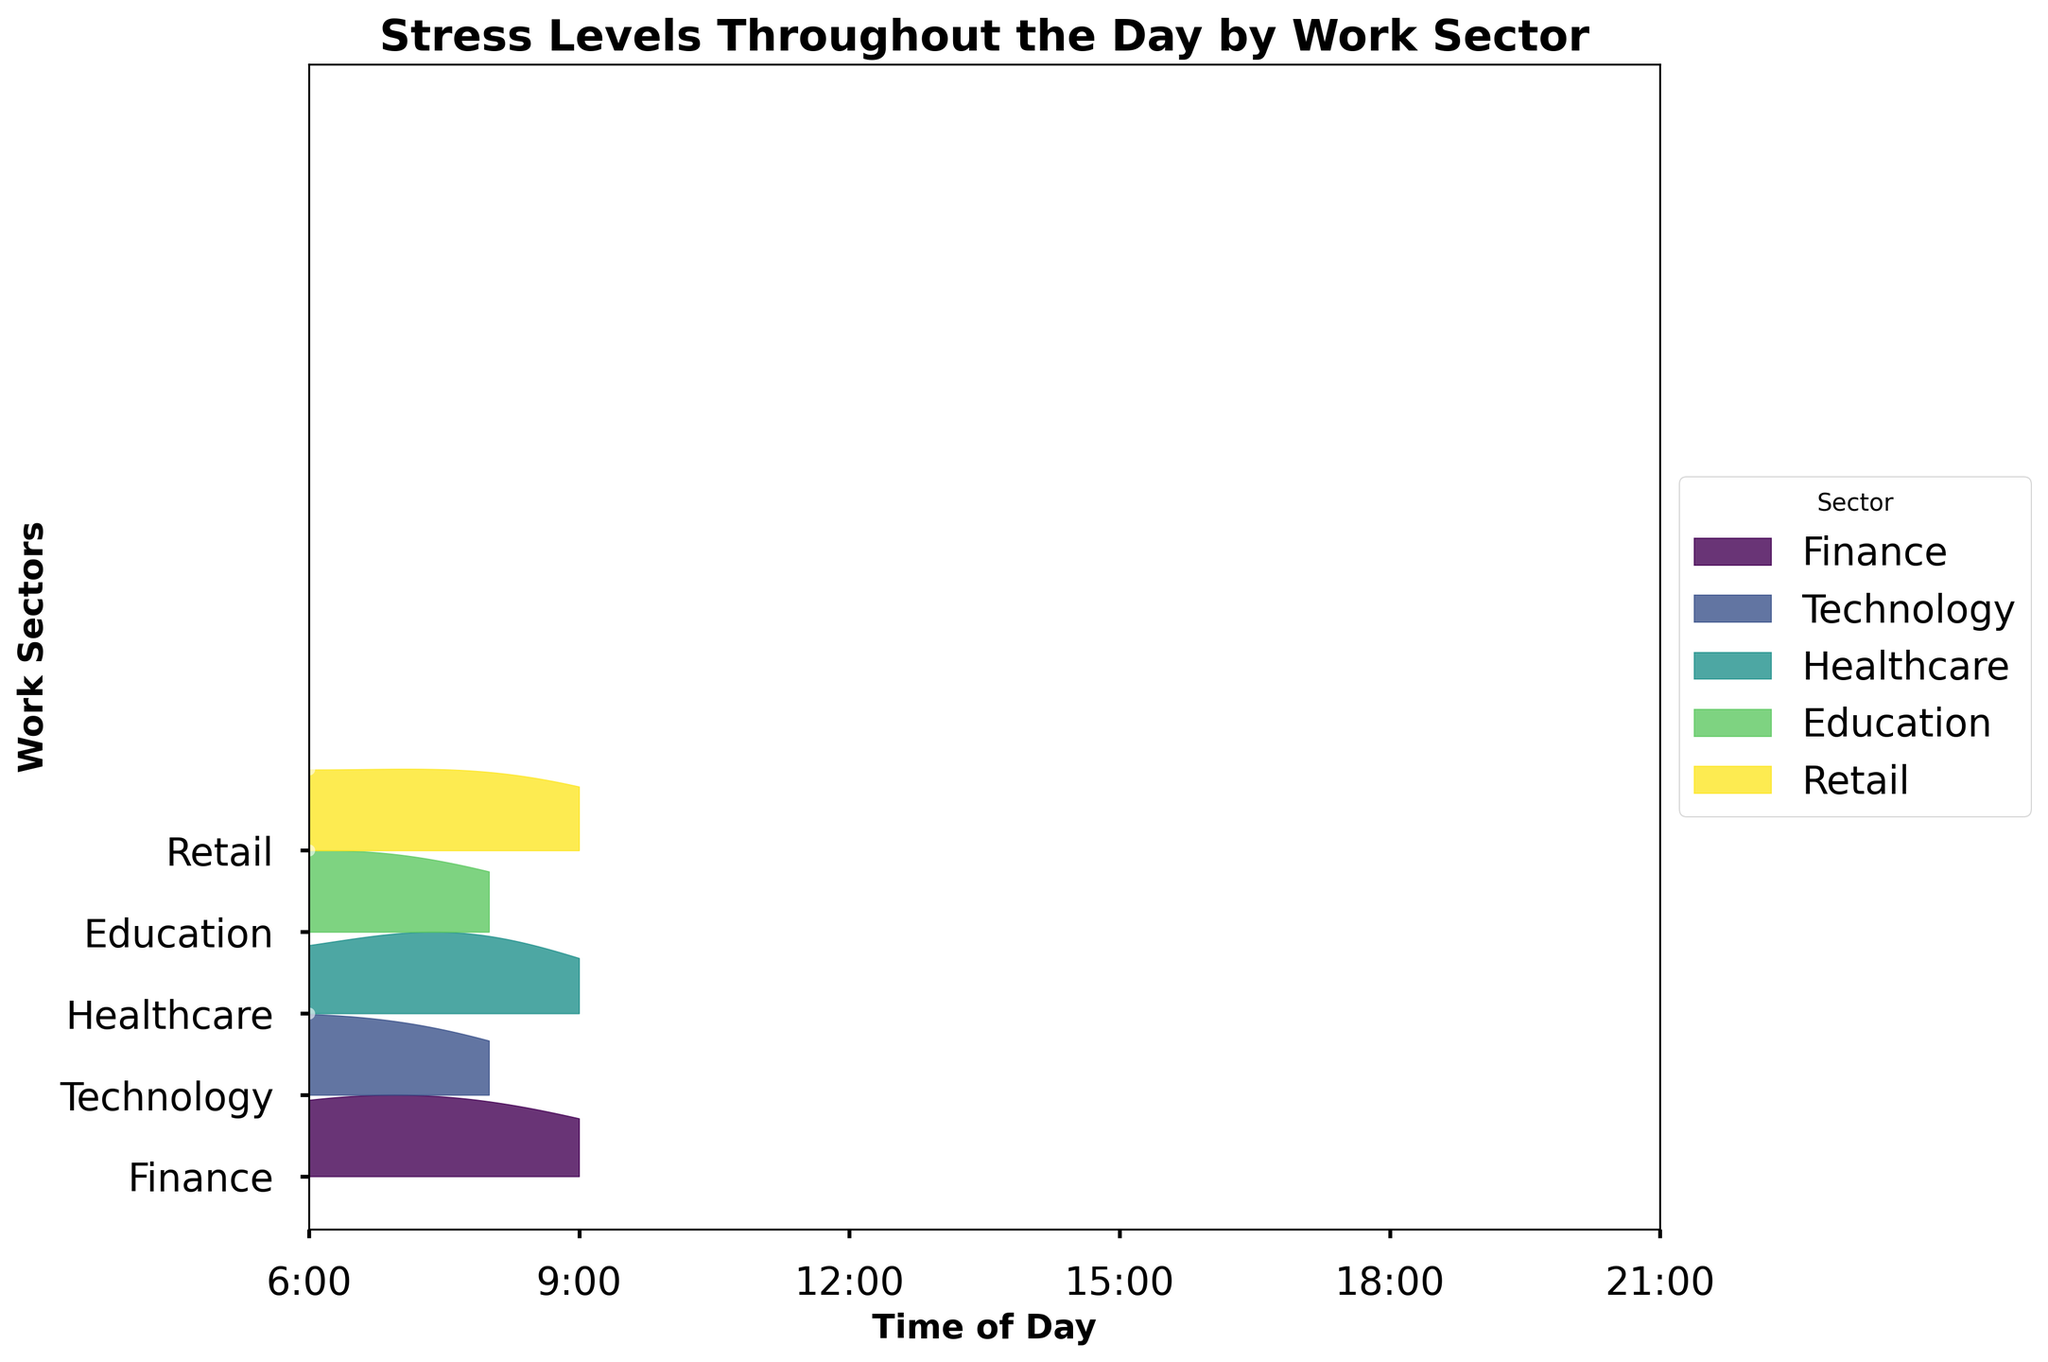What is the title of the ridgeline plot? The title of the graph is usually displayed at the top of the figure. It summarizes the content or the main point of the chart.
Answer: Stress Levels Throughout the Day by Work Sector How many work sectors are shown in the plot? Count the distinct work sectors represented along the y-axis of the graph. Each sector typically has a unique color.
Answer: 5 Which work sector shows the lowest stress level at 12:00? Locate the data points or the area at 12:00 for each work sector and identify the one with the lowest y-axis value (stress level).
Answer: Finance At what time does the Healthcare sector show the highest stress level? Check the data points or areas for the Healthcare sector and find the one with the maximum y-axis value. Note the corresponding time on the x-axis.
Answer: 12:00 Compare the stress levels in the Retail and Education sectors at 18:00. Which one is higher? Look at the stress level data points or areas at 18:00 for both Retail and Education sectors and compare their y-axis values.
Answer: Retail What's the average stress level for the Technology sector throughout the day? Sum the stress levels for the Technology sector at 6:00, 9:00, 12:00, 15:00, 18:00, and 21:00, then divide by the number of data points (6). (3+5+7+8+6+4)/6 = 33/6
Answer: 5.5 How does the stress level trend for the Finance sector from 6:00 to 21:00? Observe the data points for the Finance sector and describe how the stress level changes over time, noting any increases, decreases, or patterns.
Answer: Increases and peaks around 18:00, then decreases Which sector exhibits the most variance in stress levels throughout the day? Observe the spread of the stress level data points for each sector and identify the one with the widest range of y-axis values.
Answer: Healthcare What is the range of stress levels for the Education sector across the day? Identify the minimum and maximum stress levels for the Education sector and calculate the difference between them. Max (8 at 15:00), Min (2 at 6:00) -> 8-2
Answer: 6 Are there any sectors where stress levels are consistently low throughout the day? Which ones? Examine each sector's ridgeline for sections that stay near the lower end of the y-axis range, showing minimal fluctuation and generally low stress levels.
Answer: Finance 